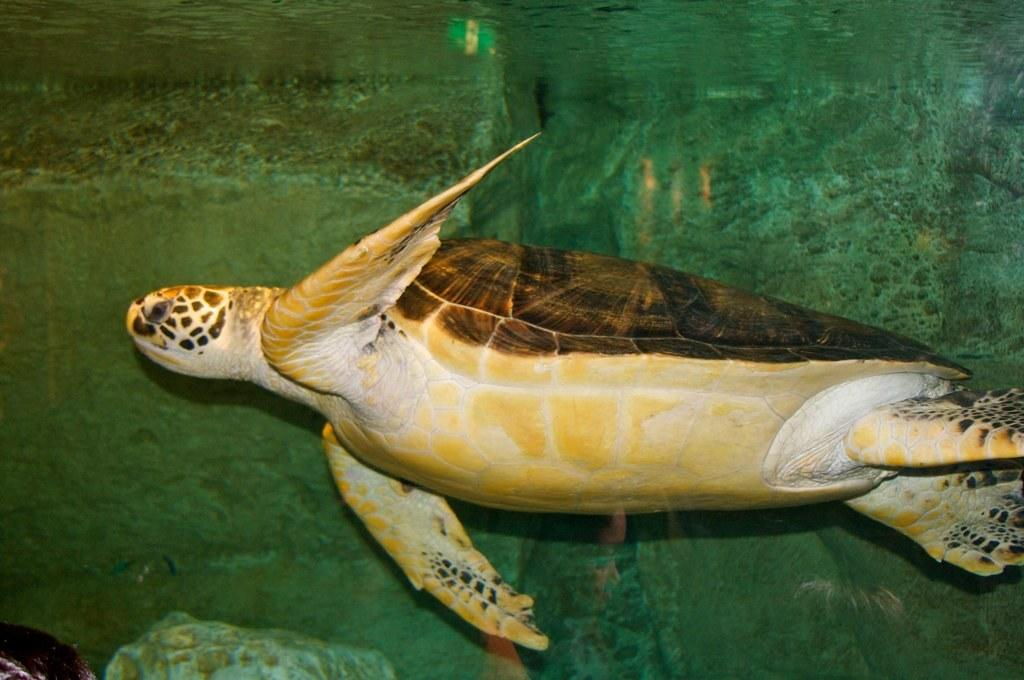What type of animal is in the image? There is a sea turtle in the image. What is the environment in which the sea turtle is located? The sea turtle is in the water in the image. Can you describe any other objects or elements in the water? There are objects in the water in the image. What type of tub is the sea turtle using to measure the liquid in the image? There is no tub or liquid present in the image, and therefore no such activity can be observed. 